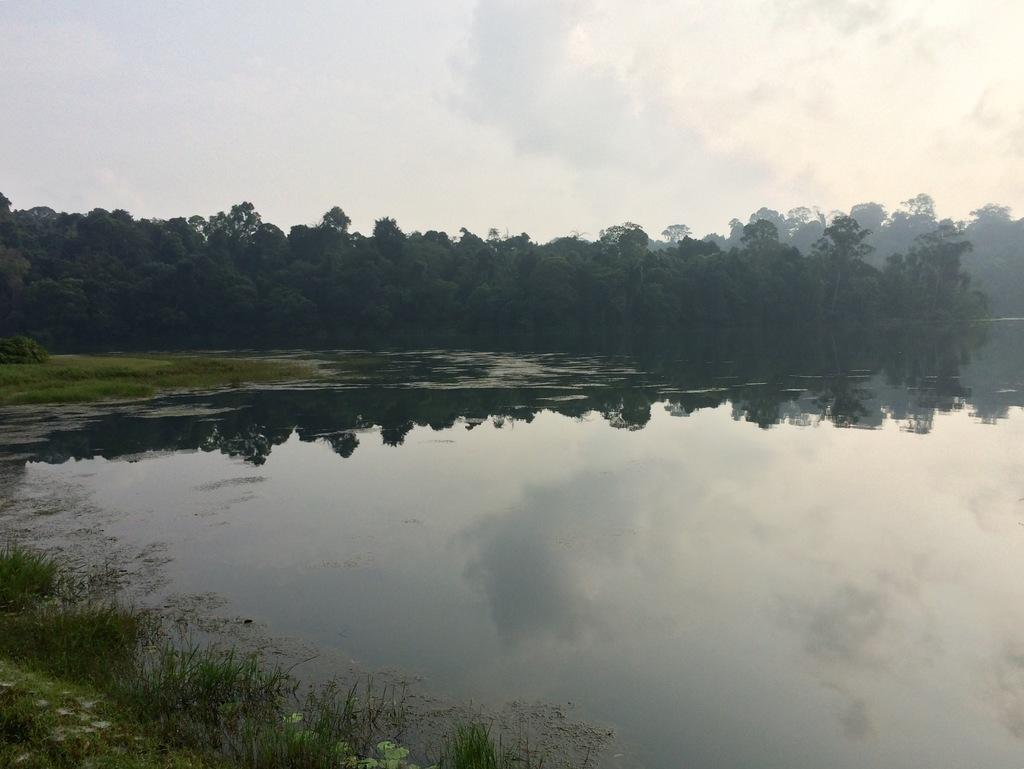What is visible in the image? Water is visible in the image. What can be seen in the background of the image? There are trees in the background of the image. What is the color of the trees? The trees are green in color. What is the color of the sky in the image? The sky is white in color. What type of creature can be seen using a sponge in the image? There is no creature present in the image, and therefore no such activity can be observed. What nerve is responsible for the color of the trees in the image? The color of the trees is a result of chlorophyll, not a specific nerve. 